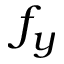Convert formula to latex. <formula><loc_0><loc_0><loc_500><loc_500>f _ { y }</formula> 